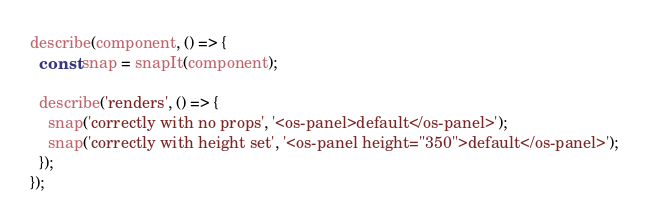Convert code to text. <code><loc_0><loc_0><loc_500><loc_500><_TypeScript_>describe(component, () => {
  const snap = snapIt(component);

  describe('renders', () => {
    snap('correctly with no props', '<os-panel>default</os-panel>');
    snap('correctly with height set', '<os-panel height="350">default</os-panel>');
  });
});
</code> 